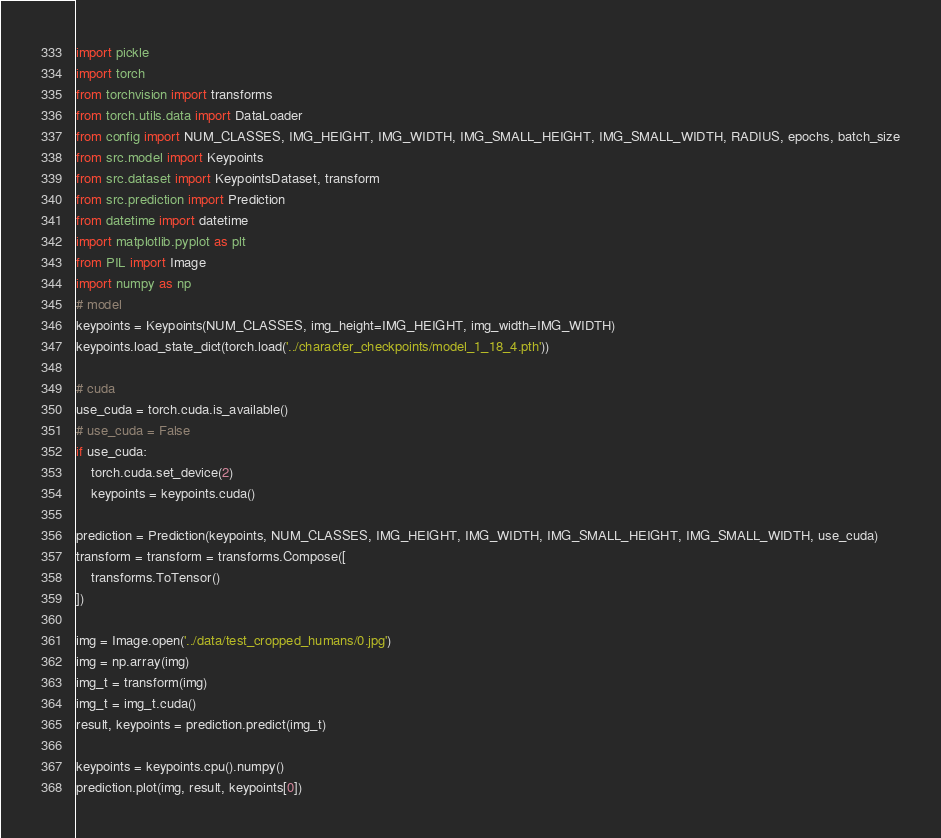<code> <loc_0><loc_0><loc_500><loc_500><_Python_>import pickle
import torch
from torchvision import transforms
from torch.utils.data import DataLoader
from config import NUM_CLASSES, IMG_HEIGHT, IMG_WIDTH, IMG_SMALL_HEIGHT, IMG_SMALL_WIDTH, RADIUS, epochs, batch_size
from src.model import Keypoints
from src.dataset import KeypointsDataset, transform
from src.prediction import Prediction
from datetime import datetime
import matplotlib.pyplot as plt
from PIL import Image
import numpy as np
# model
keypoints = Keypoints(NUM_CLASSES, img_height=IMG_HEIGHT, img_width=IMG_WIDTH)
keypoints.load_state_dict(torch.load('../character_checkpoints/model_1_18_4.pth'))

# cuda
use_cuda = torch.cuda.is_available()
# use_cuda = False
if use_cuda:
    torch.cuda.set_device(2)
    keypoints = keypoints.cuda()

prediction = Prediction(keypoints, NUM_CLASSES, IMG_HEIGHT, IMG_WIDTH, IMG_SMALL_HEIGHT, IMG_SMALL_WIDTH, use_cuda)
transform = transform = transforms.Compose([
    transforms.ToTensor()
])

img = Image.open('../data/test_cropped_humans/0.jpg')
img = np.array(img)
img_t = transform(img)
img_t = img_t.cuda()
result, keypoints = prediction.predict(img_t)

keypoints = keypoints.cpu().numpy()
prediction.plot(img, result, keypoints[0])
</code> 